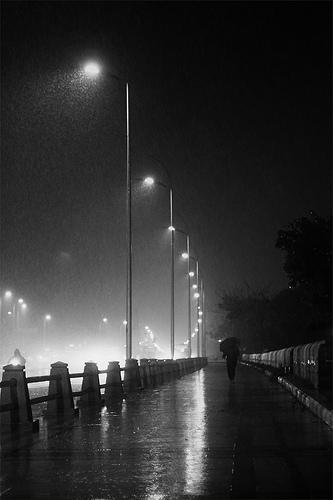Question: why are those lights blurred?
Choices:
A. Camera is too close.
B. Something on the camera lens.
C. It is raining.
D. Glare on the lens.
Answer with the letter. Answer: C Question: why does the rain look blurry?
Choices:
A. Because the man doesn't have his glasses.
B. Because of the lights.
C. Because it's dark.
D. Because it's cool.
Answer with the letter. Answer: B Question: where is this street?
Choices:
A. By the river.
B. By the beach.
C. By the lake.
D. By the grass.
Answer with the letter. Answer: A Question: who is approaching?
Choices:
A. A woman with a hat.
B. A child with a toy.
C. A man with something under his coat.
D. A dog with a bone.
Answer with the letter. Answer: C Question: how hard is it raining?
Choices:
A. Just lightly.
B. Very hard.
C. Sprinkling.
D. Misting.
Answer with the letter. Answer: A 